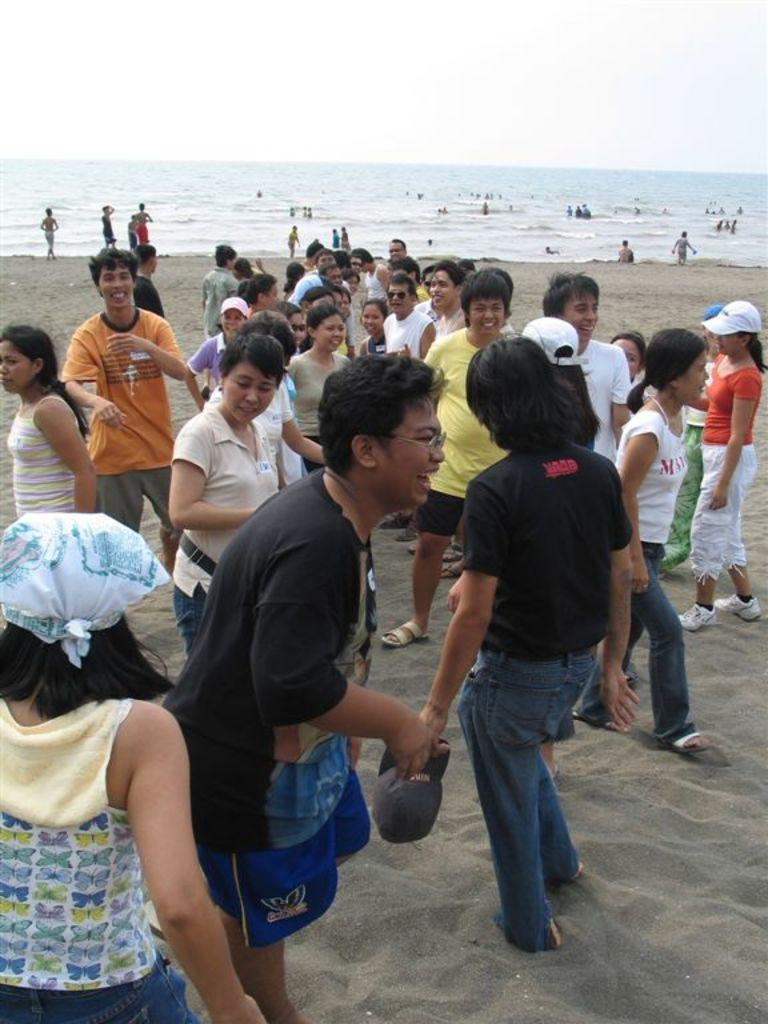What types of people are present in the image? There are men and women in the image. What activity are they engaged in? They are enjoying themselves on the beach. What natural feature can be seen in the background of the image? There is a sea visible in the background of the image. How would you describe the color of the sky in the image? The sky is white in color. What type of clover can be seen growing on the beach in the image? There is no clover present in the image; it is a beach scene with people enjoying themselves and a sea in the background. 